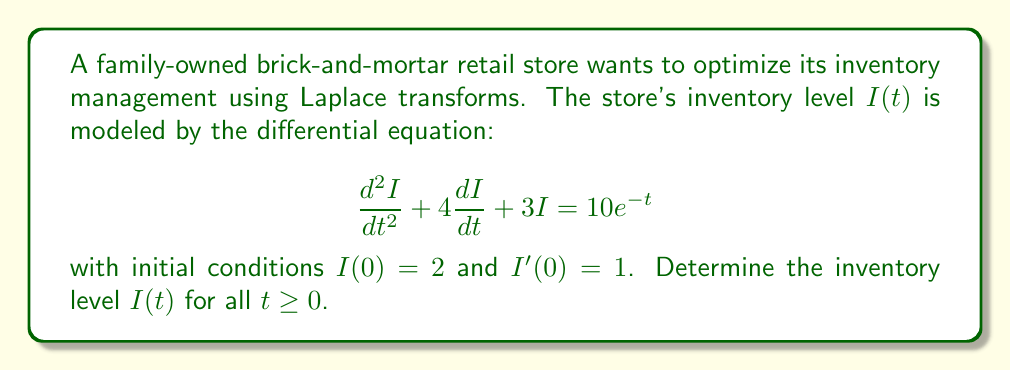What is the answer to this math problem? Let's solve this problem step-by-step using Laplace transforms:

1) Take the Laplace transform of both sides of the equation:
   $$\mathcal{L}\{I''(t) + 4I'(t) + 3I(t)\} = \mathcal{L}\{10e^{-t}\}$$

2) Using Laplace transform properties:
   $$[s^2\mathcal{L}\{I(t)\} - sI(0) - I'(0)] + 4[s\mathcal{L}\{I(t)\} - I(0)] + 3\mathcal{L}\{I(t)\} = \frac{10}{s+1}$$

3) Let $\mathcal{L}\{I(t)\} = Y(s)$. Substituting the initial conditions:
   $$s^2Y(s) - 2s - 1 + 4sY(s) - 8 + 3Y(s) = \frac{10}{s+1}$$

4) Simplify:
   $$(s^2 + 4s + 3)Y(s) = \frac{10}{s+1} + 2s + 9$$

5) Solve for $Y(s)$:
   $$Y(s) = \frac{10}{(s+1)(s^2 + 4s + 3)} + \frac{2s + 9}{s^2 + 4s + 3}$$

6) Decompose into partial fractions:
   $$Y(s) = \frac{A}{s+1} + \frac{Bs + C}{s^2 + 4s + 3}$$

   Where $A = 2$, $B = 0$, and $C = 3$

7) Therefore:
   $$Y(s) = \frac{2}{s+1} + \frac{3}{s^2 + 4s + 3}$$

8) Take the inverse Laplace transform:
   $$I(t) = 2e^{-t} + 3e^{-2t}$$

This is the solution for the inventory level $I(t)$ for all $t \geq 0$.
Answer: $I(t) = 2e^{-t} + 3e^{-2t}$ 